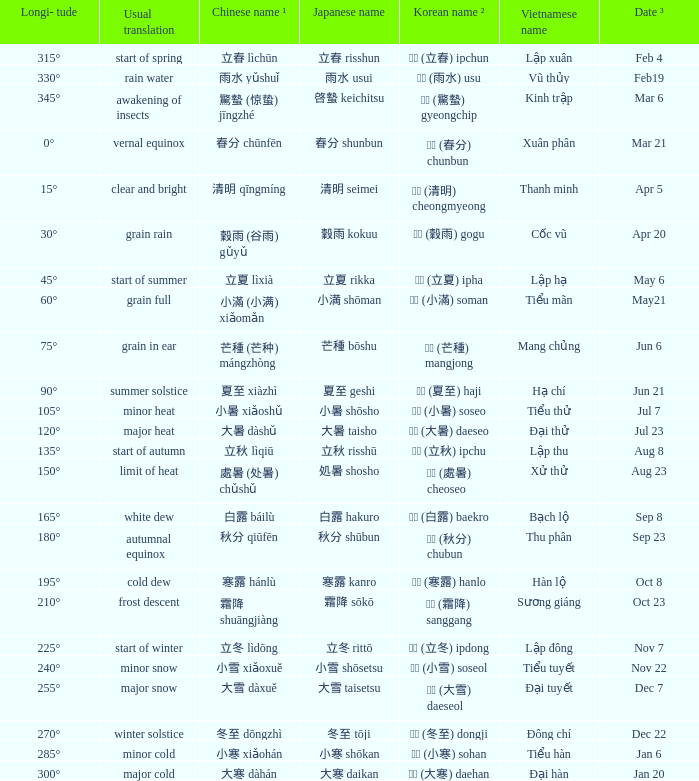What vietnamese name is associated with the chinese name 芒種 (芒种) mángzhòng? Mang chủng. 